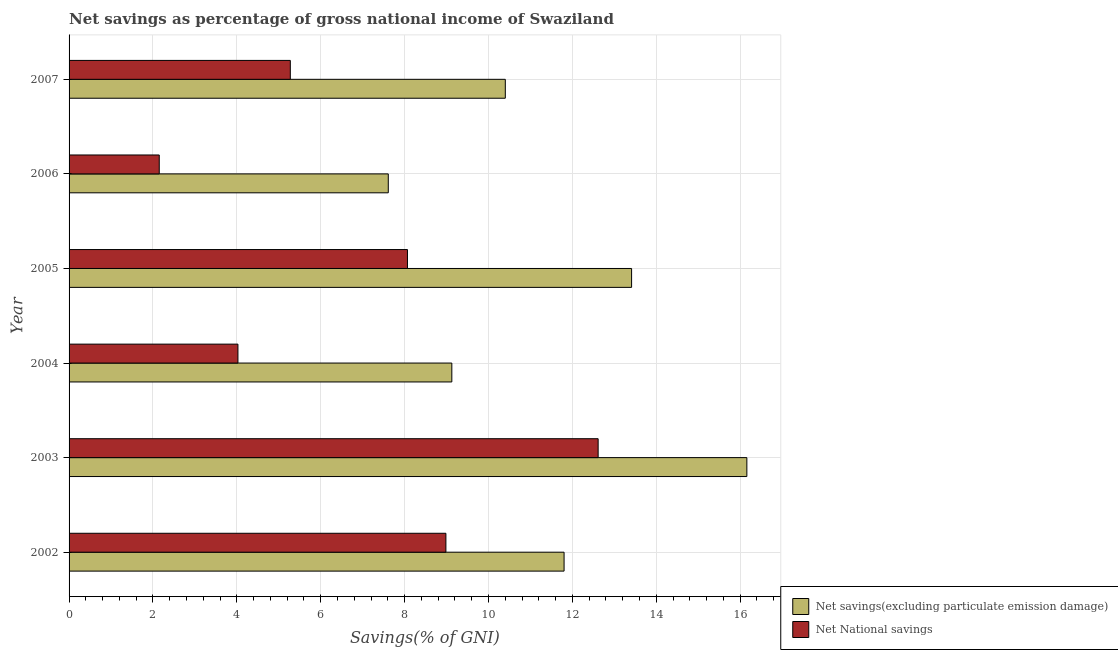How many different coloured bars are there?
Offer a terse response. 2. How many groups of bars are there?
Keep it short and to the point. 6. Are the number of bars on each tick of the Y-axis equal?
Your answer should be compact. Yes. How many bars are there on the 2nd tick from the bottom?
Your answer should be compact. 2. In how many cases, is the number of bars for a given year not equal to the number of legend labels?
Your answer should be very brief. 0. What is the net national savings in 2004?
Offer a terse response. 4.03. Across all years, what is the maximum net savings(excluding particulate emission damage)?
Offer a terse response. 16.16. Across all years, what is the minimum net savings(excluding particulate emission damage)?
Make the answer very short. 7.61. In which year was the net national savings minimum?
Ensure brevity in your answer.  2006. What is the total net savings(excluding particulate emission damage) in the graph?
Provide a succinct answer. 68.51. What is the difference between the net national savings in 2005 and that in 2006?
Keep it short and to the point. 5.92. What is the difference between the net savings(excluding particulate emission damage) in 2002 and the net national savings in 2004?
Provide a succinct answer. 7.78. What is the average net national savings per year?
Offer a very short reply. 6.85. In the year 2003, what is the difference between the net savings(excluding particulate emission damage) and net national savings?
Ensure brevity in your answer.  3.54. In how many years, is the net savings(excluding particulate emission damage) greater than 12.8 %?
Make the answer very short. 2. What is the ratio of the net savings(excluding particulate emission damage) in 2005 to that in 2007?
Your answer should be very brief. 1.29. What is the difference between the highest and the second highest net national savings?
Give a very brief answer. 3.63. What is the difference between the highest and the lowest net national savings?
Keep it short and to the point. 10.46. In how many years, is the net national savings greater than the average net national savings taken over all years?
Keep it short and to the point. 3. Is the sum of the net savings(excluding particulate emission damage) in 2003 and 2004 greater than the maximum net national savings across all years?
Offer a very short reply. Yes. What does the 2nd bar from the top in 2005 represents?
Provide a succinct answer. Net savings(excluding particulate emission damage). What does the 1st bar from the bottom in 2004 represents?
Keep it short and to the point. Net savings(excluding particulate emission damage). Are all the bars in the graph horizontal?
Keep it short and to the point. Yes. Does the graph contain any zero values?
Offer a very short reply. No. How are the legend labels stacked?
Offer a terse response. Vertical. What is the title of the graph?
Offer a very short reply. Net savings as percentage of gross national income of Swaziland. What is the label or title of the X-axis?
Your response must be concise. Savings(% of GNI). What is the label or title of the Y-axis?
Ensure brevity in your answer.  Year. What is the Savings(% of GNI) of Net savings(excluding particulate emission damage) in 2002?
Ensure brevity in your answer.  11.8. What is the Savings(% of GNI) of Net National savings in 2002?
Your response must be concise. 8.98. What is the Savings(% of GNI) in Net savings(excluding particulate emission damage) in 2003?
Provide a short and direct response. 16.16. What is the Savings(% of GNI) in Net National savings in 2003?
Provide a succinct answer. 12.61. What is the Savings(% of GNI) in Net savings(excluding particulate emission damage) in 2004?
Your answer should be compact. 9.13. What is the Savings(% of GNI) of Net National savings in 2004?
Your response must be concise. 4.03. What is the Savings(% of GNI) in Net savings(excluding particulate emission damage) in 2005?
Make the answer very short. 13.41. What is the Savings(% of GNI) in Net National savings in 2005?
Provide a short and direct response. 8.07. What is the Savings(% of GNI) in Net savings(excluding particulate emission damage) in 2006?
Give a very brief answer. 7.61. What is the Savings(% of GNI) in Net National savings in 2006?
Offer a very short reply. 2.15. What is the Savings(% of GNI) of Net savings(excluding particulate emission damage) in 2007?
Your answer should be very brief. 10.4. What is the Savings(% of GNI) of Net National savings in 2007?
Provide a short and direct response. 5.27. Across all years, what is the maximum Savings(% of GNI) in Net savings(excluding particulate emission damage)?
Provide a short and direct response. 16.16. Across all years, what is the maximum Savings(% of GNI) in Net National savings?
Offer a terse response. 12.61. Across all years, what is the minimum Savings(% of GNI) of Net savings(excluding particulate emission damage)?
Give a very brief answer. 7.61. Across all years, what is the minimum Savings(% of GNI) in Net National savings?
Your response must be concise. 2.15. What is the total Savings(% of GNI) of Net savings(excluding particulate emission damage) in the graph?
Provide a short and direct response. 68.51. What is the total Savings(% of GNI) of Net National savings in the graph?
Offer a terse response. 41.12. What is the difference between the Savings(% of GNI) of Net savings(excluding particulate emission damage) in 2002 and that in 2003?
Provide a short and direct response. -4.36. What is the difference between the Savings(% of GNI) of Net National savings in 2002 and that in 2003?
Provide a short and direct response. -3.63. What is the difference between the Savings(% of GNI) in Net savings(excluding particulate emission damage) in 2002 and that in 2004?
Provide a succinct answer. 2.68. What is the difference between the Savings(% of GNI) of Net National savings in 2002 and that in 2004?
Your response must be concise. 4.96. What is the difference between the Savings(% of GNI) in Net savings(excluding particulate emission damage) in 2002 and that in 2005?
Provide a short and direct response. -1.61. What is the difference between the Savings(% of GNI) of Net National savings in 2002 and that in 2005?
Your answer should be compact. 0.92. What is the difference between the Savings(% of GNI) of Net savings(excluding particulate emission damage) in 2002 and that in 2006?
Your answer should be compact. 4.19. What is the difference between the Savings(% of GNI) of Net National savings in 2002 and that in 2006?
Make the answer very short. 6.83. What is the difference between the Savings(% of GNI) in Net savings(excluding particulate emission damage) in 2002 and that in 2007?
Keep it short and to the point. 1.4. What is the difference between the Savings(% of GNI) in Net National savings in 2002 and that in 2007?
Ensure brevity in your answer.  3.71. What is the difference between the Savings(% of GNI) in Net savings(excluding particulate emission damage) in 2003 and that in 2004?
Give a very brief answer. 7.03. What is the difference between the Savings(% of GNI) of Net National savings in 2003 and that in 2004?
Provide a succinct answer. 8.59. What is the difference between the Savings(% of GNI) in Net savings(excluding particulate emission damage) in 2003 and that in 2005?
Provide a short and direct response. 2.75. What is the difference between the Savings(% of GNI) in Net National savings in 2003 and that in 2005?
Make the answer very short. 4.55. What is the difference between the Savings(% of GNI) of Net savings(excluding particulate emission damage) in 2003 and that in 2006?
Offer a terse response. 8.55. What is the difference between the Savings(% of GNI) of Net National savings in 2003 and that in 2006?
Make the answer very short. 10.46. What is the difference between the Savings(% of GNI) in Net savings(excluding particulate emission damage) in 2003 and that in 2007?
Your answer should be very brief. 5.76. What is the difference between the Savings(% of GNI) in Net National savings in 2003 and that in 2007?
Give a very brief answer. 7.34. What is the difference between the Savings(% of GNI) of Net savings(excluding particulate emission damage) in 2004 and that in 2005?
Make the answer very short. -4.29. What is the difference between the Savings(% of GNI) of Net National savings in 2004 and that in 2005?
Keep it short and to the point. -4.04. What is the difference between the Savings(% of GNI) in Net savings(excluding particulate emission damage) in 2004 and that in 2006?
Ensure brevity in your answer.  1.51. What is the difference between the Savings(% of GNI) in Net National savings in 2004 and that in 2006?
Give a very brief answer. 1.88. What is the difference between the Savings(% of GNI) in Net savings(excluding particulate emission damage) in 2004 and that in 2007?
Give a very brief answer. -1.28. What is the difference between the Savings(% of GNI) of Net National savings in 2004 and that in 2007?
Your answer should be very brief. -1.25. What is the difference between the Savings(% of GNI) in Net savings(excluding particulate emission damage) in 2005 and that in 2006?
Your answer should be compact. 5.8. What is the difference between the Savings(% of GNI) of Net National savings in 2005 and that in 2006?
Your answer should be very brief. 5.92. What is the difference between the Savings(% of GNI) in Net savings(excluding particulate emission damage) in 2005 and that in 2007?
Make the answer very short. 3.01. What is the difference between the Savings(% of GNI) in Net National savings in 2005 and that in 2007?
Give a very brief answer. 2.79. What is the difference between the Savings(% of GNI) in Net savings(excluding particulate emission damage) in 2006 and that in 2007?
Make the answer very short. -2.79. What is the difference between the Savings(% of GNI) in Net National savings in 2006 and that in 2007?
Offer a terse response. -3.12. What is the difference between the Savings(% of GNI) in Net savings(excluding particulate emission damage) in 2002 and the Savings(% of GNI) in Net National savings in 2003?
Give a very brief answer. -0.81. What is the difference between the Savings(% of GNI) of Net savings(excluding particulate emission damage) in 2002 and the Savings(% of GNI) of Net National savings in 2004?
Your answer should be compact. 7.78. What is the difference between the Savings(% of GNI) of Net savings(excluding particulate emission damage) in 2002 and the Savings(% of GNI) of Net National savings in 2005?
Your answer should be compact. 3.73. What is the difference between the Savings(% of GNI) of Net savings(excluding particulate emission damage) in 2002 and the Savings(% of GNI) of Net National savings in 2006?
Give a very brief answer. 9.65. What is the difference between the Savings(% of GNI) in Net savings(excluding particulate emission damage) in 2002 and the Savings(% of GNI) in Net National savings in 2007?
Offer a terse response. 6.53. What is the difference between the Savings(% of GNI) in Net savings(excluding particulate emission damage) in 2003 and the Savings(% of GNI) in Net National savings in 2004?
Keep it short and to the point. 12.13. What is the difference between the Savings(% of GNI) in Net savings(excluding particulate emission damage) in 2003 and the Savings(% of GNI) in Net National savings in 2005?
Your response must be concise. 8.09. What is the difference between the Savings(% of GNI) of Net savings(excluding particulate emission damage) in 2003 and the Savings(% of GNI) of Net National savings in 2006?
Your response must be concise. 14.01. What is the difference between the Savings(% of GNI) in Net savings(excluding particulate emission damage) in 2003 and the Savings(% of GNI) in Net National savings in 2007?
Make the answer very short. 10.88. What is the difference between the Savings(% of GNI) in Net savings(excluding particulate emission damage) in 2004 and the Savings(% of GNI) in Net National savings in 2005?
Your answer should be compact. 1.06. What is the difference between the Savings(% of GNI) of Net savings(excluding particulate emission damage) in 2004 and the Savings(% of GNI) of Net National savings in 2006?
Your answer should be very brief. 6.98. What is the difference between the Savings(% of GNI) of Net savings(excluding particulate emission damage) in 2004 and the Savings(% of GNI) of Net National savings in 2007?
Keep it short and to the point. 3.85. What is the difference between the Savings(% of GNI) of Net savings(excluding particulate emission damage) in 2005 and the Savings(% of GNI) of Net National savings in 2006?
Offer a terse response. 11.26. What is the difference between the Savings(% of GNI) in Net savings(excluding particulate emission damage) in 2005 and the Savings(% of GNI) in Net National savings in 2007?
Give a very brief answer. 8.14. What is the difference between the Savings(% of GNI) in Net savings(excluding particulate emission damage) in 2006 and the Savings(% of GNI) in Net National savings in 2007?
Your response must be concise. 2.34. What is the average Savings(% of GNI) in Net savings(excluding particulate emission damage) per year?
Your answer should be very brief. 11.42. What is the average Savings(% of GNI) in Net National savings per year?
Make the answer very short. 6.85. In the year 2002, what is the difference between the Savings(% of GNI) of Net savings(excluding particulate emission damage) and Savings(% of GNI) of Net National savings?
Your response must be concise. 2.82. In the year 2003, what is the difference between the Savings(% of GNI) in Net savings(excluding particulate emission damage) and Savings(% of GNI) in Net National savings?
Your answer should be very brief. 3.55. In the year 2004, what is the difference between the Savings(% of GNI) of Net savings(excluding particulate emission damage) and Savings(% of GNI) of Net National savings?
Offer a terse response. 5.1. In the year 2005, what is the difference between the Savings(% of GNI) in Net savings(excluding particulate emission damage) and Savings(% of GNI) in Net National savings?
Keep it short and to the point. 5.34. In the year 2006, what is the difference between the Savings(% of GNI) of Net savings(excluding particulate emission damage) and Savings(% of GNI) of Net National savings?
Provide a succinct answer. 5.46. In the year 2007, what is the difference between the Savings(% of GNI) in Net savings(excluding particulate emission damage) and Savings(% of GNI) in Net National savings?
Ensure brevity in your answer.  5.13. What is the ratio of the Savings(% of GNI) in Net savings(excluding particulate emission damage) in 2002 to that in 2003?
Give a very brief answer. 0.73. What is the ratio of the Savings(% of GNI) of Net National savings in 2002 to that in 2003?
Your answer should be compact. 0.71. What is the ratio of the Savings(% of GNI) of Net savings(excluding particulate emission damage) in 2002 to that in 2004?
Offer a terse response. 1.29. What is the ratio of the Savings(% of GNI) in Net National savings in 2002 to that in 2004?
Offer a very short reply. 2.23. What is the ratio of the Savings(% of GNI) of Net National savings in 2002 to that in 2005?
Offer a terse response. 1.11. What is the ratio of the Savings(% of GNI) of Net savings(excluding particulate emission damage) in 2002 to that in 2006?
Make the answer very short. 1.55. What is the ratio of the Savings(% of GNI) of Net National savings in 2002 to that in 2006?
Ensure brevity in your answer.  4.18. What is the ratio of the Savings(% of GNI) in Net savings(excluding particulate emission damage) in 2002 to that in 2007?
Your response must be concise. 1.13. What is the ratio of the Savings(% of GNI) of Net National savings in 2002 to that in 2007?
Provide a succinct answer. 1.7. What is the ratio of the Savings(% of GNI) of Net savings(excluding particulate emission damage) in 2003 to that in 2004?
Provide a short and direct response. 1.77. What is the ratio of the Savings(% of GNI) of Net National savings in 2003 to that in 2004?
Offer a terse response. 3.13. What is the ratio of the Savings(% of GNI) in Net savings(excluding particulate emission damage) in 2003 to that in 2005?
Give a very brief answer. 1.2. What is the ratio of the Savings(% of GNI) in Net National savings in 2003 to that in 2005?
Offer a very short reply. 1.56. What is the ratio of the Savings(% of GNI) of Net savings(excluding particulate emission damage) in 2003 to that in 2006?
Your answer should be compact. 2.12. What is the ratio of the Savings(% of GNI) of Net National savings in 2003 to that in 2006?
Give a very brief answer. 5.87. What is the ratio of the Savings(% of GNI) of Net savings(excluding particulate emission damage) in 2003 to that in 2007?
Offer a terse response. 1.55. What is the ratio of the Savings(% of GNI) of Net National savings in 2003 to that in 2007?
Offer a terse response. 2.39. What is the ratio of the Savings(% of GNI) of Net savings(excluding particulate emission damage) in 2004 to that in 2005?
Provide a succinct answer. 0.68. What is the ratio of the Savings(% of GNI) in Net National savings in 2004 to that in 2005?
Ensure brevity in your answer.  0.5. What is the ratio of the Savings(% of GNI) of Net savings(excluding particulate emission damage) in 2004 to that in 2006?
Offer a very short reply. 1.2. What is the ratio of the Savings(% of GNI) of Net National savings in 2004 to that in 2006?
Keep it short and to the point. 1.87. What is the ratio of the Savings(% of GNI) in Net savings(excluding particulate emission damage) in 2004 to that in 2007?
Make the answer very short. 0.88. What is the ratio of the Savings(% of GNI) in Net National savings in 2004 to that in 2007?
Provide a succinct answer. 0.76. What is the ratio of the Savings(% of GNI) in Net savings(excluding particulate emission damage) in 2005 to that in 2006?
Your answer should be compact. 1.76. What is the ratio of the Savings(% of GNI) of Net National savings in 2005 to that in 2006?
Keep it short and to the point. 3.75. What is the ratio of the Savings(% of GNI) of Net savings(excluding particulate emission damage) in 2005 to that in 2007?
Make the answer very short. 1.29. What is the ratio of the Savings(% of GNI) in Net National savings in 2005 to that in 2007?
Keep it short and to the point. 1.53. What is the ratio of the Savings(% of GNI) in Net savings(excluding particulate emission damage) in 2006 to that in 2007?
Provide a short and direct response. 0.73. What is the ratio of the Savings(% of GNI) of Net National savings in 2006 to that in 2007?
Ensure brevity in your answer.  0.41. What is the difference between the highest and the second highest Savings(% of GNI) in Net savings(excluding particulate emission damage)?
Give a very brief answer. 2.75. What is the difference between the highest and the second highest Savings(% of GNI) in Net National savings?
Provide a short and direct response. 3.63. What is the difference between the highest and the lowest Savings(% of GNI) of Net savings(excluding particulate emission damage)?
Offer a terse response. 8.55. What is the difference between the highest and the lowest Savings(% of GNI) of Net National savings?
Keep it short and to the point. 10.46. 